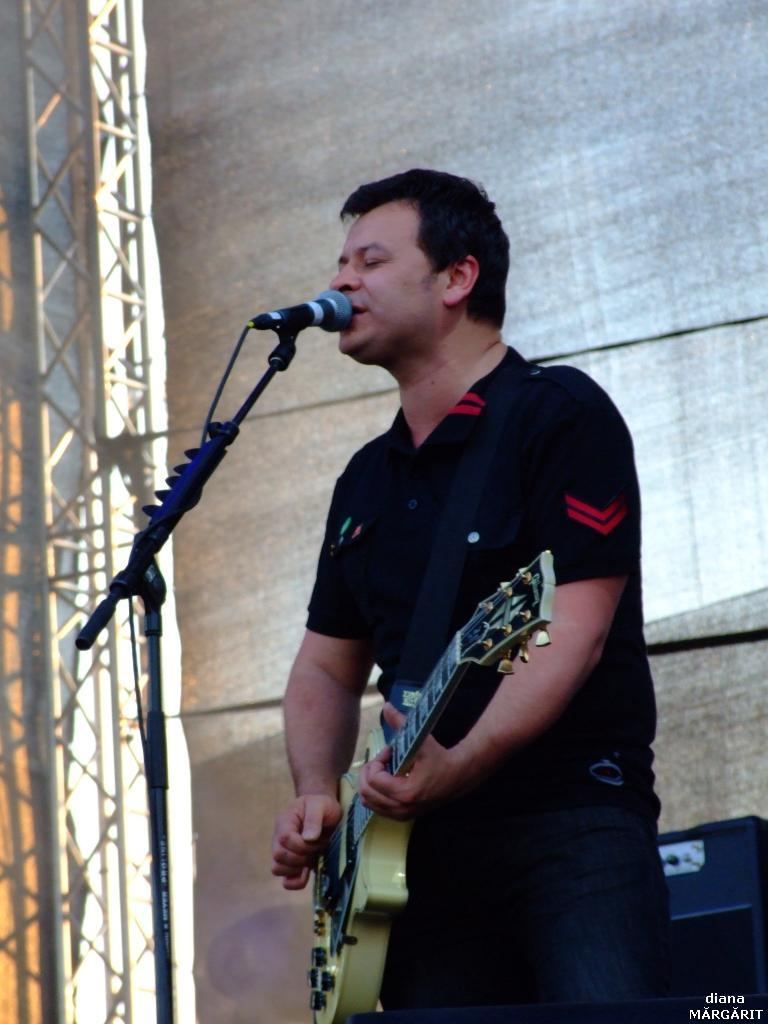What is the person in the image doing? The person is playing a guitar. What object is located on the left side of the image? There is a microphone stand on the left side of the image. What can be seen at the right bottom of the image? A watermark is present at the right bottom of the image. What type of material is visible on the left side of the image? Metal rods are visible on the left side of the image. What color are the person's eyes in the image? The person's eyes are not visible in the image, so their color cannot be determined. 